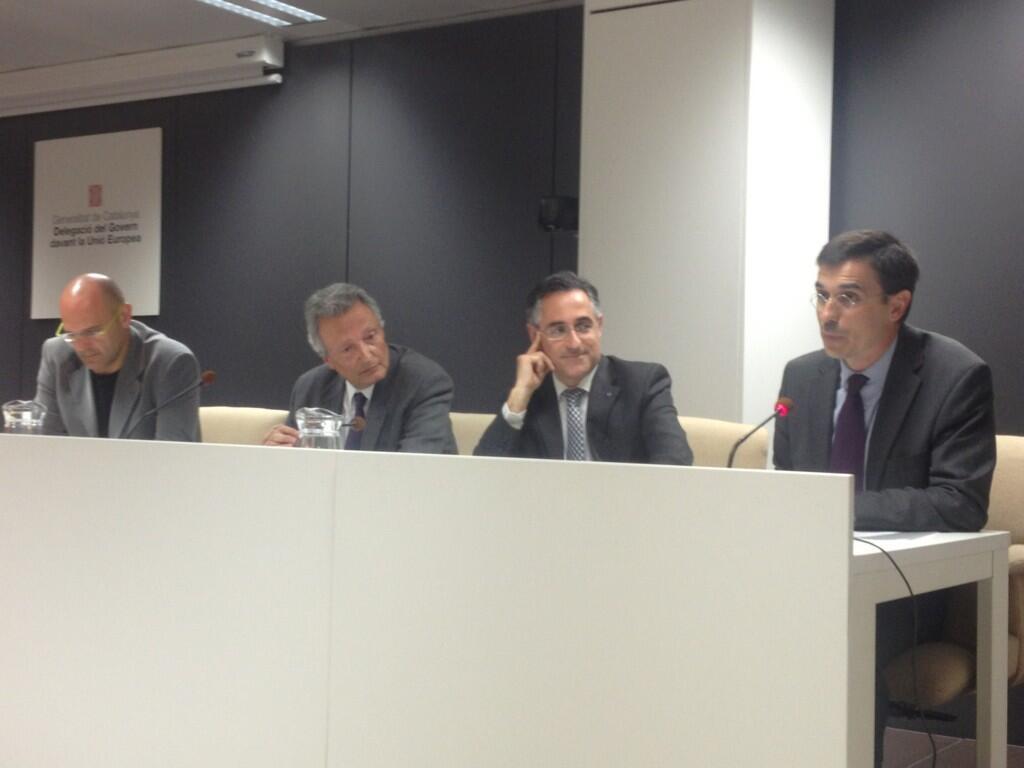How would you summarize this image in a sentence or two? As we can see in the image there are few people wearing black color dresses and sitting on chairs. There is a wall, banner and a table. On table there are mugs. 